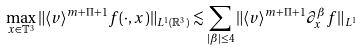<formula> <loc_0><loc_0><loc_500><loc_500>\max _ { x \in \mathbb { T } ^ { 3 } } \| \langle v \rangle ^ { m + \Pi + 1 } f ( \cdot , x ) \| _ { L ^ { 1 } ( \mathbb { R } ^ { 3 } ) } \lesssim \sum _ { | \beta | \leq 4 } \| \langle v \rangle ^ { m + \Pi + 1 } \partial _ { x } ^ { \beta } f \| _ { L ^ { 1 } }</formula> 